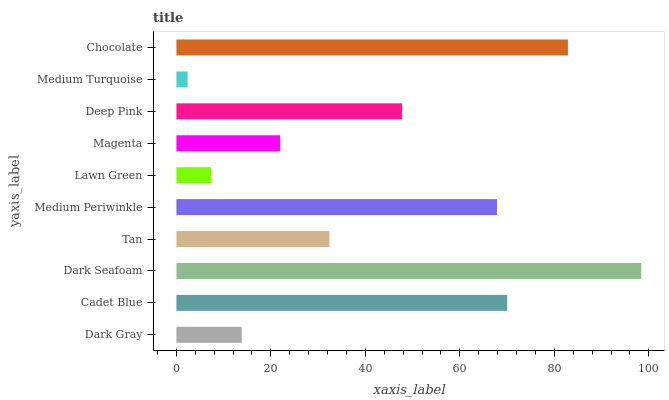Is Medium Turquoise the minimum?
Answer yes or no. Yes. Is Dark Seafoam the maximum?
Answer yes or no. Yes. Is Cadet Blue the minimum?
Answer yes or no. No. Is Cadet Blue the maximum?
Answer yes or no. No. Is Cadet Blue greater than Dark Gray?
Answer yes or no. Yes. Is Dark Gray less than Cadet Blue?
Answer yes or no. Yes. Is Dark Gray greater than Cadet Blue?
Answer yes or no. No. Is Cadet Blue less than Dark Gray?
Answer yes or no. No. Is Deep Pink the high median?
Answer yes or no. Yes. Is Tan the low median?
Answer yes or no. Yes. Is Medium Periwinkle the high median?
Answer yes or no. No. Is Deep Pink the low median?
Answer yes or no. No. 